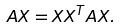<formula> <loc_0><loc_0><loc_500><loc_500>A X = X X ^ { T } A X .</formula> 